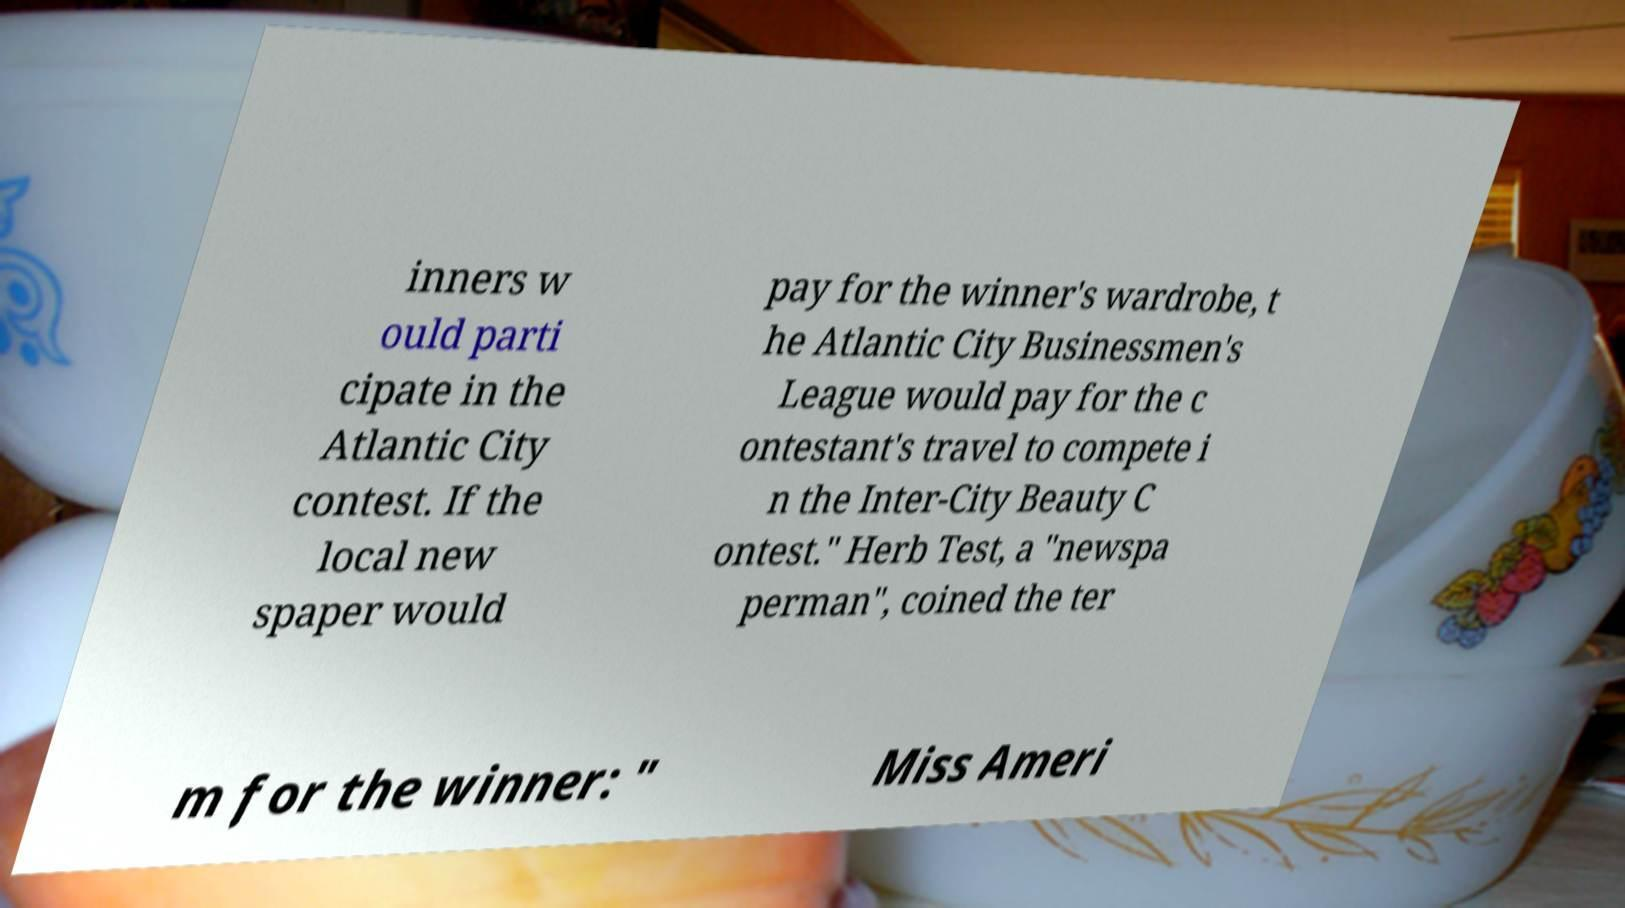For documentation purposes, I need the text within this image transcribed. Could you provide that? inners w ould parti cipate in the Atlantic City contest. If the local new spaper would pay for the winner's wardrobe, t he Atlantic City Businessmen's League would pay for the c ontestant's travel to compete i n the Inter-City Beauty C ontest." Herb Test, a "newspa perman", coined the ter m for the winner: " Miss Ameri 